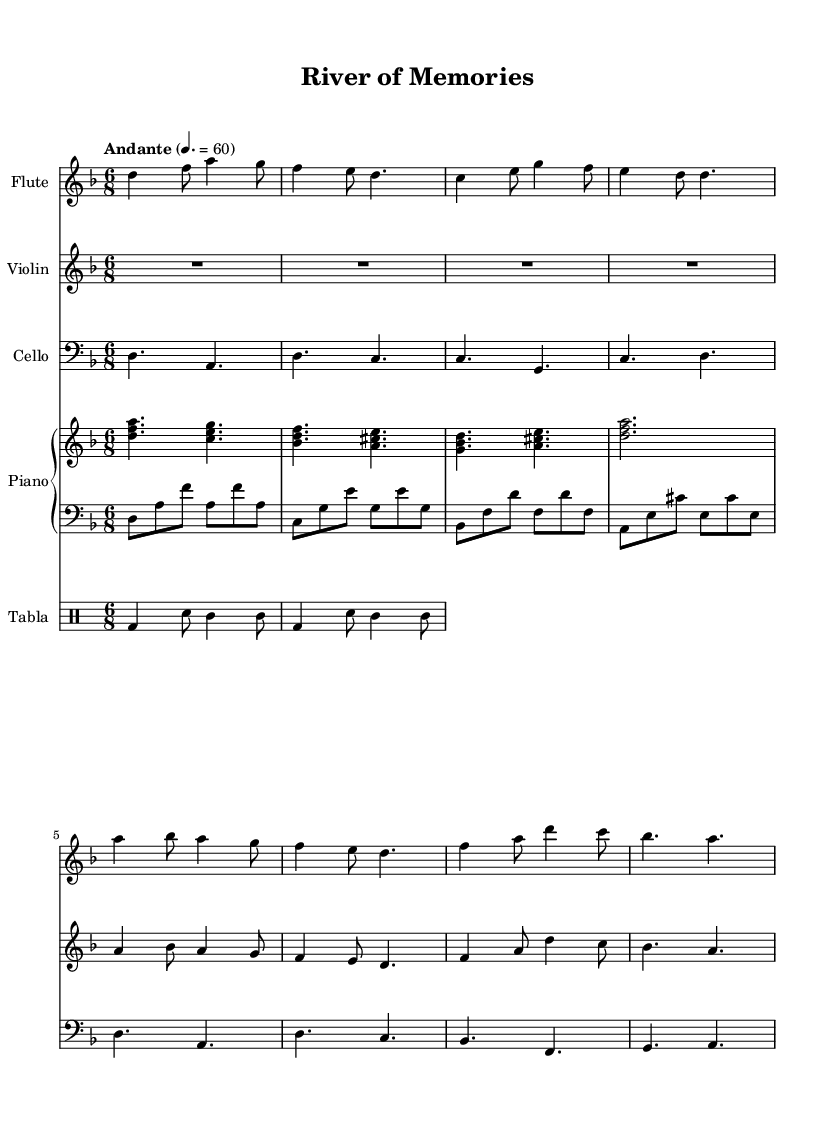What is the key signature of this music? The key signature is two flats (B♭ and E♭), as indicated by the symbol at the beginning of the staff. This tells us that the piece is in D minor, which has one flat in its relative major, F major.
Answer: D minor What is the time signature of this music? The time signature is indicated at the beginning of the staff as 6/8, which denotes a compound duple meter, where there are six eighth notes per measure.
Answer: 6/8 What is the tempo marking of this piece? The tempo marking is noted as "Andante" with a speed of 60 beats per minute. This indicates a moderately slow tempo, a common characteristic of Romantic music.
Answer: Andante How many instruments are included in this score? The score includes five instruments: flute, violin, cello, piano, and tabla. Each instrument is represented by its own staff, showing their distinct parts in the composition.
Answer: Five Which instrument has the highest pitch in this composition? The flute typically plays in a higher register compared to the other instruments in the score. Based on its notation, we can see it frequently employs higher notes within the staff.
Answer: Flute What is the rhythmic pattern used in the tabla part? The tabla part features a pattern that combines bass drum hits and snare hits, creating a syncopated rhythm typical of traditional Bengali rhythms, enhancing the fusion aspect of the score.
Answer: Bass and snare (bd, sn) Describe the role of the piano in this composition. The piano plays both a right-hand melody and a left-hand accompaniment, providing harmonic support and rhythmic foundation. This dual role enriches the overall texture while blending both Western and Bengali styles.
Answer: Harmony and melody 